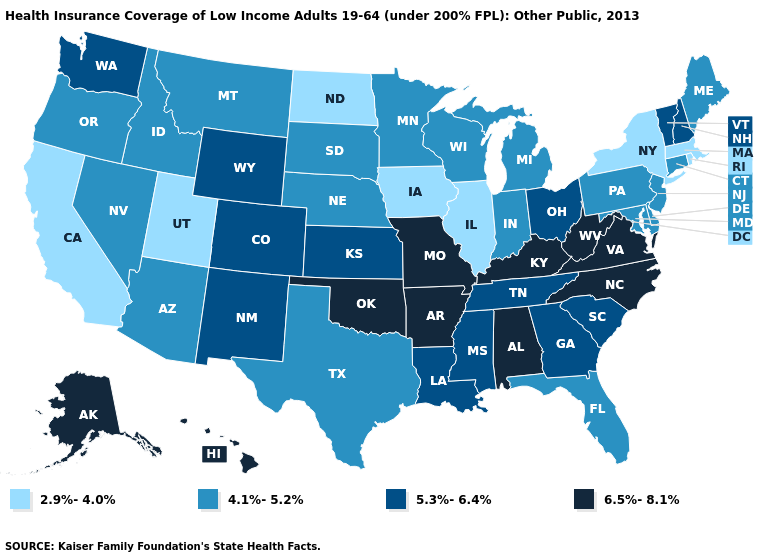Does Idaho have a higher value than Rhode Island?
Keep it brief. Yes. Name the states that have a value in the range 5.3%-6.4%?
Short answer required. Colorado, Georgia, Kansas, Louisiana, Mississippi, New Hampshire, New Mexico, Ohio, South Carolina, Tennessee, Vermont, Washington, Wyoming. Does the map have missing data?
Give a very brief answer. No. Which states hav the highest value in the Northeast?
Short answer required. New Hampshire, Vermont. What is the value of Indiana?
Be succinct. 4.1%-5.2%. What is the lowest value in the West?
Short answer required. 2.9%-4.0%. Name the states that have a value in the range 2.9%-4.0%?
Write a very short answer. California, Illinois, Iowa, Massachusetts, New York, North Dakota, Rhode Island, Utah. Does North Carolina have the same value as Connecticut?
Quick response, please. No. What is the value of Tennessee?
Be succinct. 5.3%-6.4%. What is the highest value in states that border Michigan?
Give a very brief answer. 5.3%-6.4%. Does New Jersey have the same value as Connecticut?
Quick response, please. Yes. Name the states that have a value in the range 4.1%-5.2%?
Short answer required. Arizona, Connecticut, Delaware, Florida, Idaho, Indiana, Maine, Maryland, Michigan, Minnesota, Montana, Nebraska, Nevada, New Jersey, Oregon, Pennsylvania, South Dakota, Texas, Wisconsin. Which states have the lowest value in the USA?
Short answer required. California, Illinois, Iowa, Massachusetts, New York, North Dakota, Rhode Island, Utah. Does Connecticut have a lower value than Tennessee?
Short answer required. Yes. 